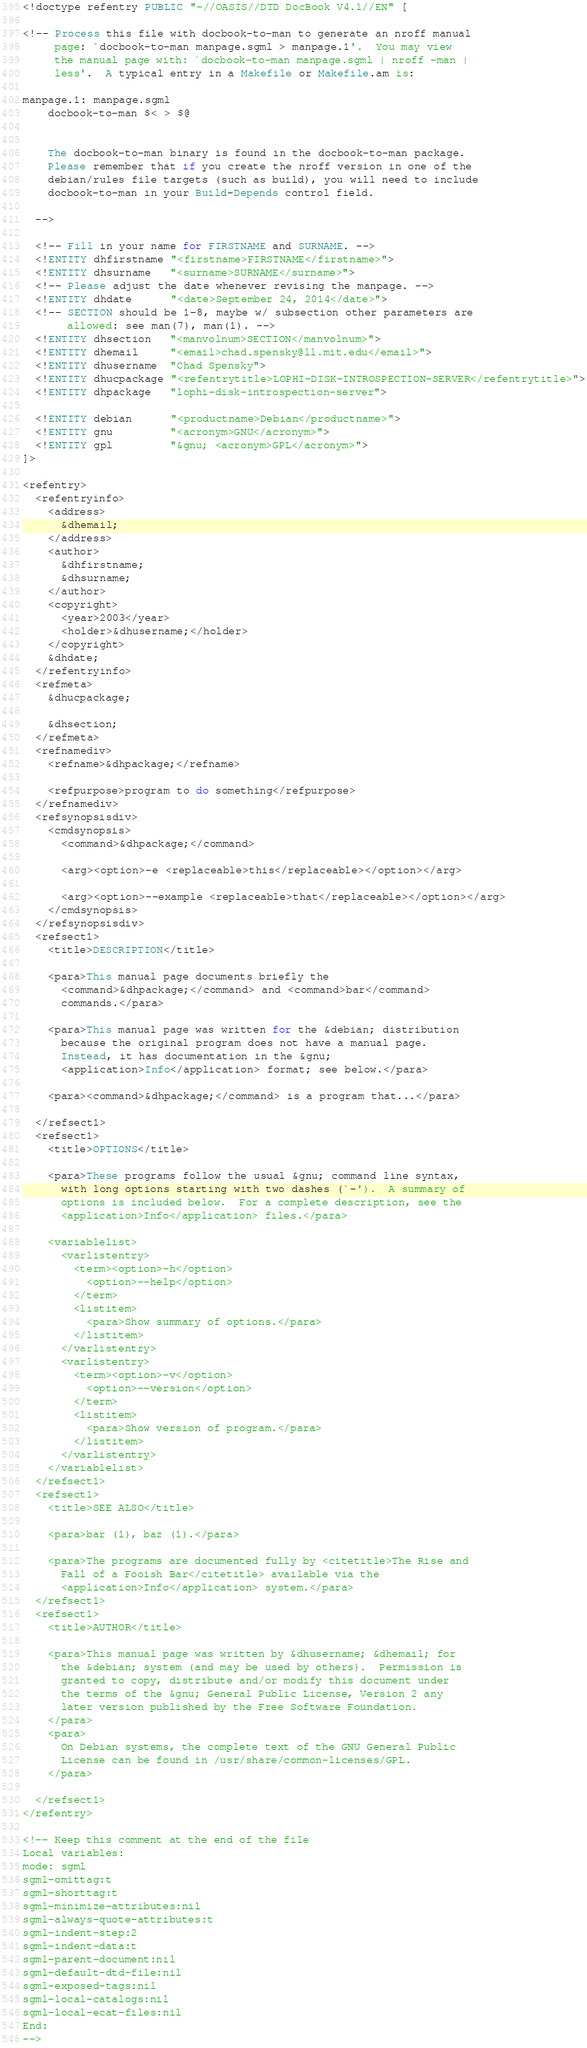<code> <loc_0><loc_0><loc_500><loc_500><_Elixir_><!doctype refentry PUBLIC "-//OASIS//DTD DocBook V4.1//EN" [

<!-- Process this file with docbook-to-man to generate an nroff manual
     page: `docbook-to-man manpage.sgml > manpage.1'.  You may view
     the manual page with: `docbook-to-man manpage.sgml | nroff -man |
     less'.  A typical entry in a Makefile or Makefile.am is:

manpage.1: manpage.sgml
	docbook-to-man $< > $@


	The docbook-to-man binary is found in the docbook-to-man package.
	Please remember that if you create the nroff version in one of the
	debian/rules file targets (such as build), you will need to include
	docbook-to-man in your Build-Depends control field.

  -->

  <!-- Fill in your name for FIRSTNAME and SURNAME. -->
  <!ENTITY dhfirstname "<firstname>FIRSTNAME</firstname>">
  <!ENTITY dhsurname   "<surname>SURNAME</surname>">
  <!-- Please adjust the date whenever revising the manpage. -->
  <!ENTITY dhdate      "<date>September 24, 2014</date>">
  <!-- SECTION should be 1-8, maybe w/ subsection other parameters are
       allowed: see man(7), man(1). -->
  <!ENTITY dhsection   "<manvolnum>SECTION</manvolnum>">
  <!ENTITY dhemail     "<email>chad.spensky@ll.mit.edu</email>">
  <!ENTITY dhusername  "Chad Spensky">
  <!ENTITY dhucpackage "<refentrytitle>LOPHI-DISK-INTROSPECTION-SERVER</refentrytitle>">
  <!ENTITY dhpackage   "lophi-disk-introspection-server">

  <!ENTITY debian      "<productname>Debian</productname>">
  <!ENTITY gnu         "<acronym>GNU</acronym>">
  <!ENTITY gpl         "&gnu; <acronym>GPL</acronym>">
]>

<refentry>
  <refentryinfo>
    <address>
      &dhemail;
    </address>
    <author>
      &dhfirstname;
      &dhsurname;
    </author>
    <copyright>
      <year>2003</year>
      <holder>&dhusername;</holder>
    </copyright>
    &dhdate;
  </refentryinfo>
  <refmeta>
    &dhucpackage;

    &dhsection;
  </refmeta>
  <refnamediv>
    <refname>&dhpackage;</refname>

    <refpurpose>program to do something</refpurpose>
  </refnamediv>
  <refsynopsisdiv>
    <cmdsynopsis>
      <command>&dhpackage;</command>

      <arg><option>-e <replaceable>this</replaceable></option></arg>

      <arg><option>--example <replaceable>that</replaceable></option></arg>
    </cmdsynopsis>
  </refsynopsisdiv>
  <refsect1>
    <title>DESCRIPTION</title>

    <para>This manual page documents briefly the
      <command>&dhpackage;</command> and <command>bar</command>
      commands.</para>

    <para>This manual page was written for the &debian; distribution
      because the original program does not have a manual page.
      Instead, it has documentation in the &gnu;
      <application>Info</application> format; see below.</para>

    <para><command>&dhpackage;</command> is a program that...</para>

  </refsect1>
  <refsect1>
    <title>OPTIONS</title>

    <para>These programs follow the usual &gnu; command line syntax,
      with long options starting with two dashes (`-').  A summary of
      options is included below.  For a complete description, see the
      <application>Info</application> files.</para>

    <variablelist>
      <varlistentry>
        <term><option>-h</option>
          <option>--help</option>
        </term>
        <listitem>
          <para>Show summary of options.</para>
        </listitem>
      </varlistentry>
      <varlistentry>
        <term><option>-v</option>
          <option>--version</option>
        </term>
        <listitem>
          <para>Show version of program.</para>
        </listitem>
      </varlistentry>
    </variablelist>
  </refsect1>
  <refsect1>
    <title>SEE ALSO</title>

    <para>bar (1), baz (1).</para>

    <para>The programs are documented fully by <citetitle>The Rise and
      Fall of a Fooish Bar</citetitle> available via the
      <application>Info</application> system.</para>
  </refsect1>
  <refsect1>
    <title>AUTHOR</title>

    <para>This manual page was written by &dhusername; &dhemail; for
      the &debian; system (and may be used by others).  Permission is
      granted to copy, distribute and/or modify this document under
      the terms of the &gnu; General Public License, Version 2 any
      later version published by the Free Software Foundation.
    </para>
    <para>
      On Debian systems, the complete text of the GNU General Public
      License can be found in /usr/share/common-licenses/GPL.
    </para>

  </refsect1>
</refentry>

<!-- Keep this comment at the end of the file
Local variables:
mode: sgml
sgml-omittag:t
sgml-shorttag:t
sgml-minimize-attributes:nil
sgml-always-quote-attributes:t
sgml-indent-step:2
sgml-indent-data:t
sgml-parent-document:nil
sgml-default-dtd-file:nil
sgml-exposed-tags:nil
sgml-local-catalogs:nil
sgml-local-ecat-files:nil
End:
-->
</code> 